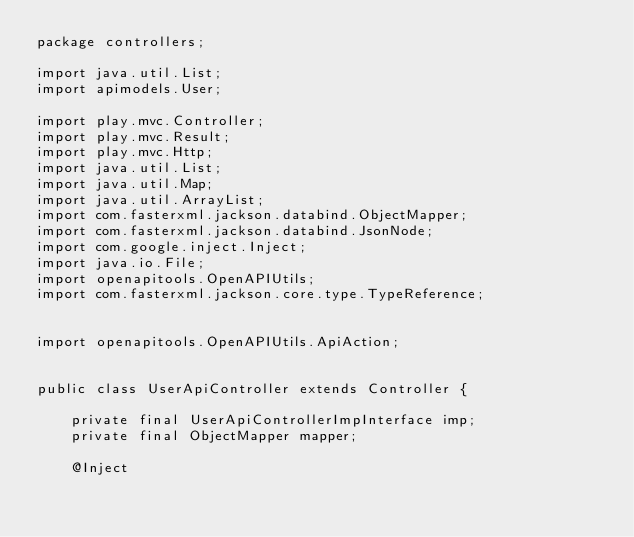<code> <loc_0><loc_0><loc_500><loc_500><_Java_>package controllers;

import java.util.List;
import apimodels.User;

import play.mvc.Controller;
import play.mvc.Result;
import play.mvc.Http;
import java.util.List;
import java.util.Map;
import java.util.ArrayList;
import com.fasterxml.jackson.databind.ObjectMapper;
import com.fasterxml.jackson.databind.JsonNode;
import com.google.inject.Inject;
import java.io.File;
import openapitools.OpenAPIUtils;
import com.fasterxml.jackson.core.type.TypeReference;


import openapitools.OpenAPIUtils.ApiAction;


public class UserApiController extends Controller {

    private final UserApiControllerImpInterface imp;
    private final ObjectMapper mapper;

    @Inject</code> 